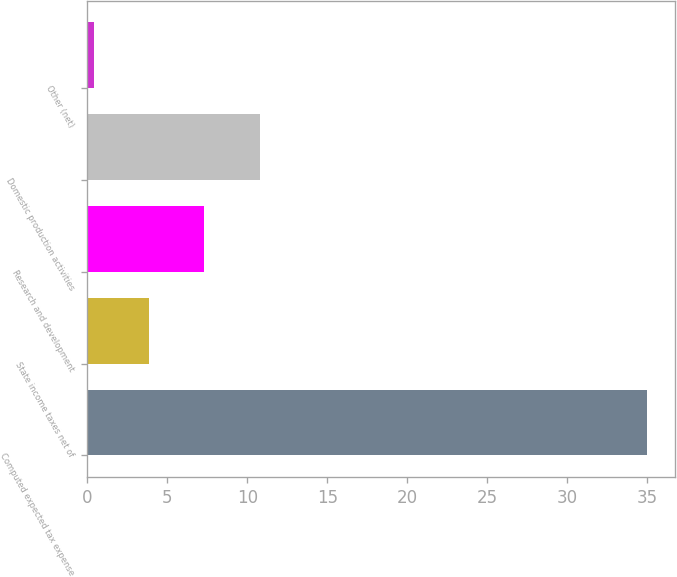Convert chart to OTSL. <chart><loc_0><loc_0><loc_500><loc_500><bar_chart><fcel>Computed expected tax expense<fcel>State income taxes net of<fcel>Research and development<fcel>Domestic production activities<fcel>Other (net)<nl><fcel>35<fcel>3.86<fcel>7.32<fcel>10.78<fcel>0.4<nl></chart> 